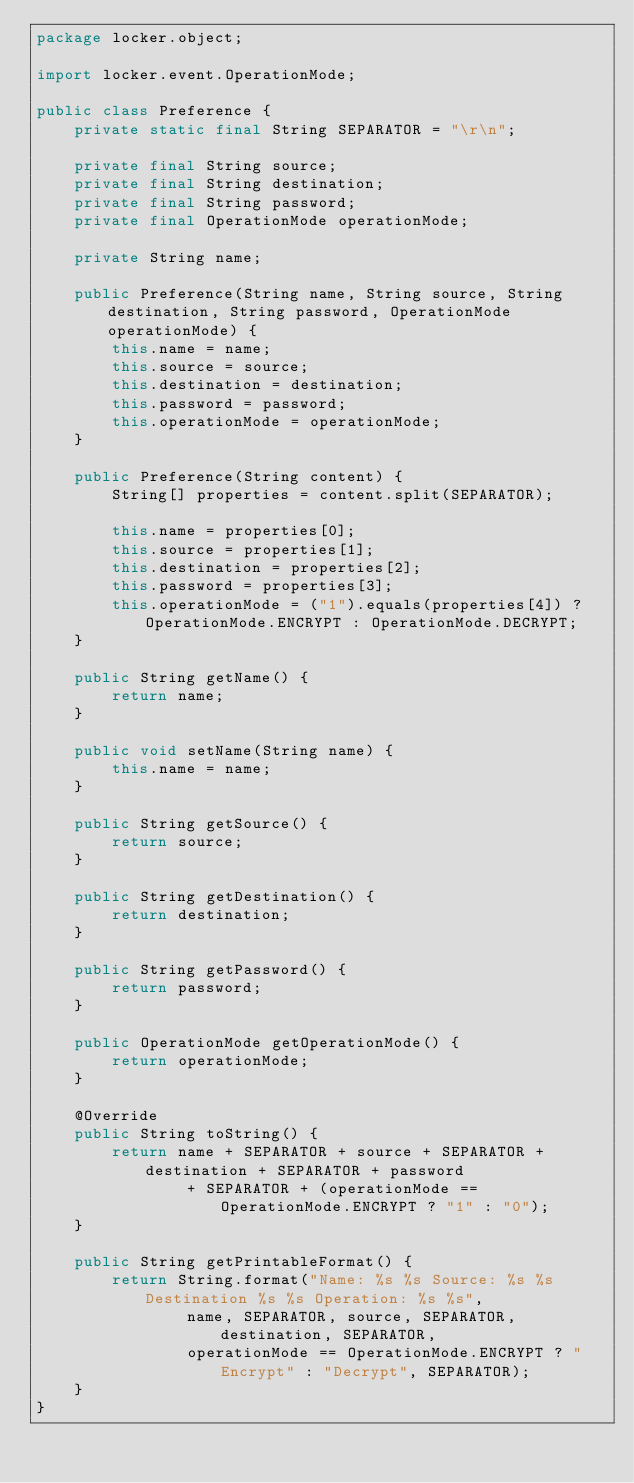Convert code to text. <code><loc_0><loc_0><loc_500><loc_500><_Java_>package locker.object;

import locker.event.OperationMode;

public class Preference {
    private static final String SEPARATOR = "\r\n";

    private final String source;
    private final String destination;
    private final String password;
    private final OperationMode operationMode;

    private String name;

    public Preference(String name, String source, String destination, String password, OperationMode operationMode) {
        this.name = name;
        this.source = source;
        this.destination = destination;
        this.password = password;
        this.operationMode = operationMode;
    }

    public Preference(String content) {
        String[] properties = content.split(SEPARATOR);

        this.name = properties[0];
        this.source = properties[1];
        this.destination = properties[2];
        this.password = properties[3];
        this.operationMode = ("1").equals(properties[4]) ? OperationMode.ENCRYPT : OperationMode.DECRYPT;
    }

    public String getName() {
        return name;
    }

    public void setName(String name) {
        this.name = name;
    }

    public String getSource() {
        return source;
    }

    public String getDestination() {
        return destination;
    }

    public String getPassword() {
        return password;
    }

    public OperationMode getOperationMode() {
        return operationMode;
    }

    @Override
    public String toString() {
        return name + SEPARATOR + source + SEPARATOR + destination + SEPARATOR + password
                + SEPARATOR + (operationMode == OperationMode.ENCRYPT ? "1" : "0");
    }

    public String getPrintableFormat() {
        return String.format("Name: %s %s Source: %s %s Destination %s %s Operation: %s %s",
                name, SEPARATOR, source, SEPARATOR, destination, SEPARATOR,
                operationMode == OperationMode.ENCRYPT ? "Encrypt" : "Decrypt", SEPARATOR);
    }
}
</code> 